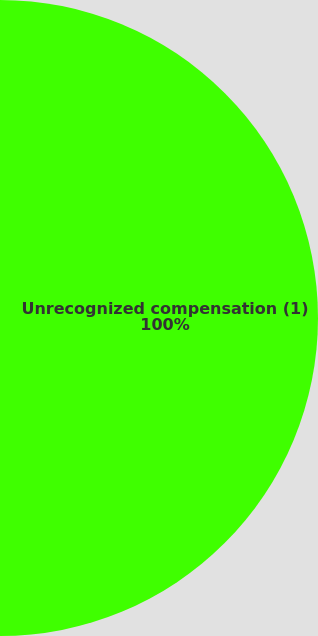<chart> <loc_0><loc_0><loc_500><loc_500><pie_chart><fcel>Unrecognized compensation (1)<fcel>Weighted average period of<nl><fcel>100.0%<fcel>0.0%<nl></chart> 